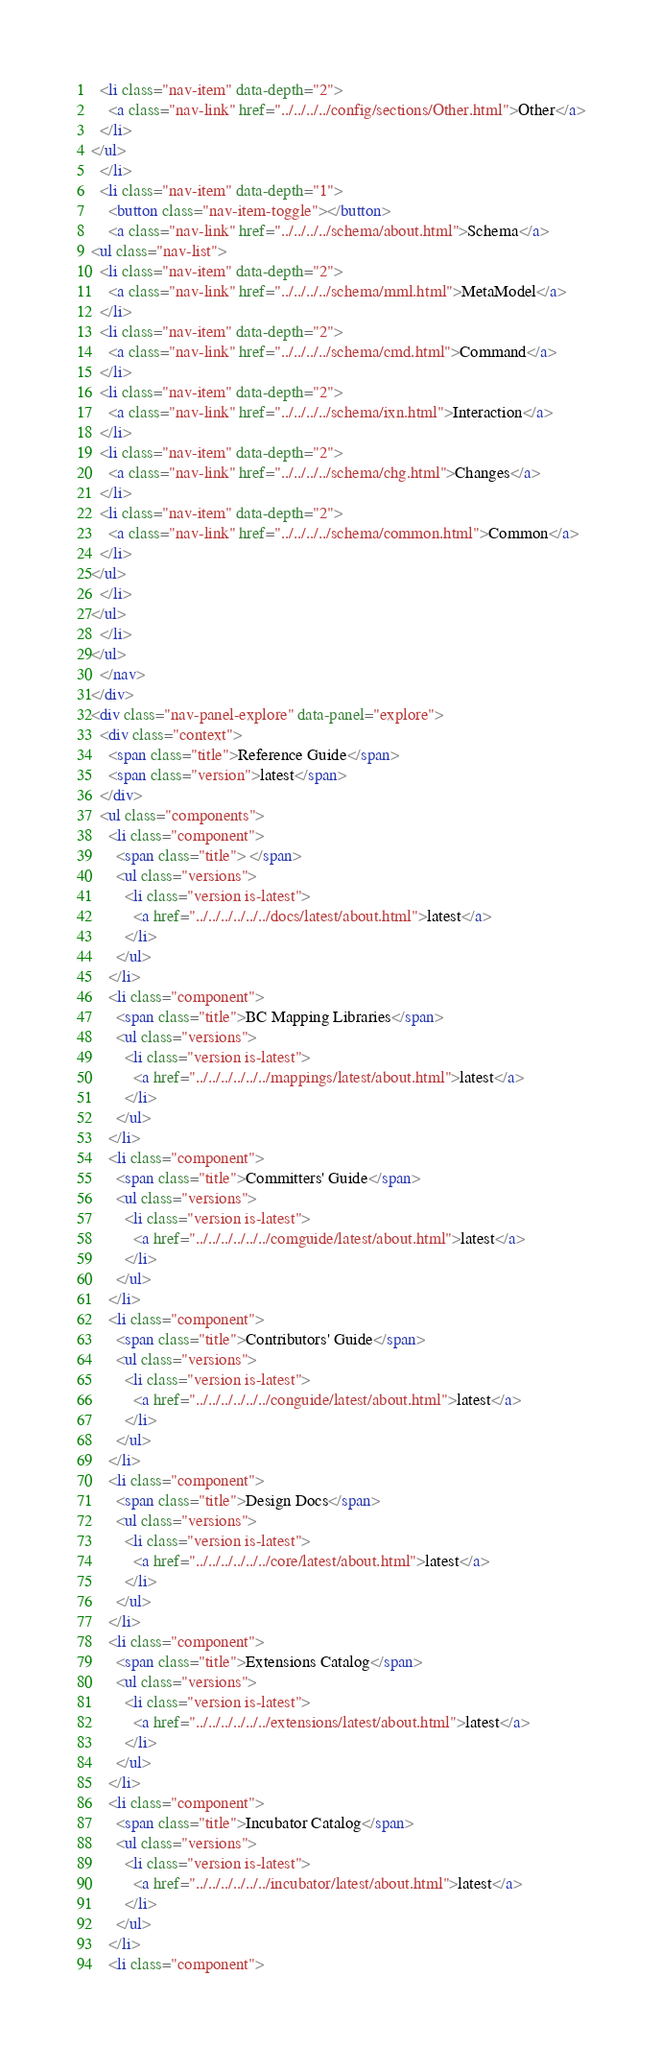<code> <loc_0><loc_0><loc_500><loc_500><_HTML_>  <li class="nav-item" data-depth="2">
    <a class="nav-link" href="../../../../config/sections/Other.html">Other</a>
  </li>
</ul>
  </li>
  <li class="nav-item" data-depth="1">
    <button class="nav-item-toggle"></button>
    <a class="nav-link" href="../../../../schema/about.html">Schema</a>
<ul class="nav-list">
  <li class="nav-item" data-depth="2">
    <a class="nav-link" href="../../../../schema/mml.html">MetaModel</a>
  </li>
  <li class="nav-item" data-depth="2">
    <a class="nav-link" href="../../../../schema/cmd.html">Command</a>
  </li>
  <li class="nav-item" data-depth="2">
    <a class="nav-link" href="../../../../schema/ixn.html">Interaction</a>
  </li>
  <li class="nav-item" data-depth="2">
    <a class="nav-link" href="../../../../schema/chg.html">Changes</a>
  </li>
  <li class="nav-item" data-depth="2">
    <a class="nav-link" href="../../../../schema/common.html">Common</a>
  </li>
</ul>
  </li>
</ul>
  </li>
</ul>
  </nav>
</div>
<div class="nav-panel-explore" data-panel="explore">
  <div class="context">
    <span class="title">Reference Guide</span>
    <span class="version">latest</span>
  </div>
  <ul class="components">
    <li class="component">
      <span class="title"> </span>
      <ul class="versions">
        <li class="version is-latest">
          <a href="../../../../../../docs/latest/about.html">latest</a>
        </li>
      </ul>
    </li>
    <li class="component">
      <span class="title">BC Mapping Libraries</span>
      <ul class="versions">
        <li class="version is-latest">
          <a href="../../../../../../mappings/latest/about.html">latest</a>
        </li>
      </ul>
    </li>
    <li class="component">
      <span class="title">Committers' Guide</span>
      <ul class="versions">
        <li class="version is-latest">
          <a href="../../../../../../comguide/latest/about.html">latest</a>
        </li>
      </ul>
    </li>
    <li class="component">
      <span class="title">Contributors' Guide</span>
      <ul class="versions">
        <li class="version is-latest">
          <a href="../../../../../../conguide/latest/about.html">latest</a>
        </li>
      </ul>
    </li>
    <li class="component">
      <span class="title">Design Docs</span>
      <ul class="versions">
        <li class="version is-latest">
          <a href="../../../../../../core/latest/about.html">latest</a>
        </li>
      </ul>
    </li>
    <li class="component">
      <span class="title">Extensions Catalog</span>
      <ul class="versions">
        <li class="version is-latest">
          <a href="../../../../../../extensions/latest/about.html">latest</a>
        </li>
      </ul>
    </li>
    <li class="component">
      <span class="title">Incubator Catalog</span>
      <ul class="versions">
        <li class="version is-latest">
          <a href="../../../../../../incubator/latest/about.html">latest</a>
        </li>
      </ul>
    </li>
    <li class="component"></code> 